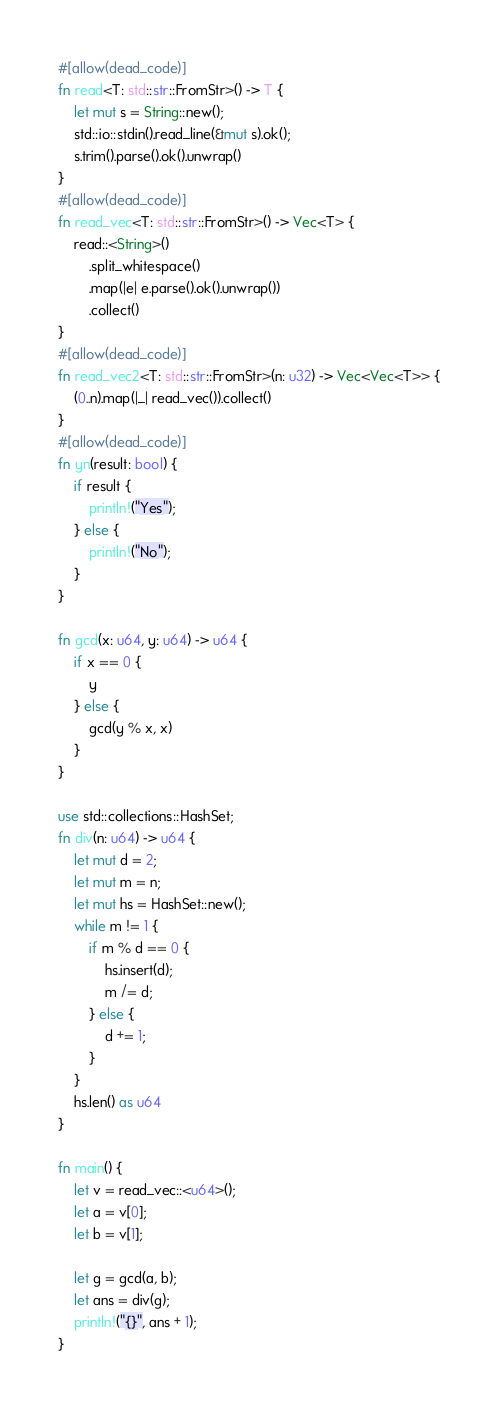<code> <loc_0><loc_0><loc_500><loc_500><_Rust_>#[allow(dead_code)]
fn read<T: std::str::FromStr>() -> T {
    let mut s = String::new();
    std::io::stdin().read_line(&mut s).ok();
    s.trim().parse().ok().unwrap()
}
#[allow(dead_code)]
fn read_vec<T: std::str::FromStr>() -> Vec<T> {
    read::<String>()
        .split_whitespace()
        .map(|e| e.parse().ok().unwrap())
        .collect()
}
#[allow(dead_code)]
fn read_vec2<T: std::str::FromStr>(n: u32) -> Vec<Vec<T>> {
    (0..n).map(|_| read_vec()).collect()
}
#[allow(dead_code)]
fn yn(result: bool) {
    if result {
        println!("Yes");
    } else {
        println!("No");
    }
}

fn gcd(x: u64, y: u64) -> u64 {
    if x == 0 {
        y
    } else {
        gcd(y % x, x)
    }
}

use std::collections::HashSet;
fn div(n: u64) -> u64 {
    let mut d = 2;
    let mut m = n;
    let mut hs = HashSet::new();
    while m != 1 {
        if m % d == 0 {
            hs.insert(d);
            m /= d;
        } else {
            d += 1;
        }
    }
    hs.len() as u64
}

fn main() {
    let v = read_vec::<u64>();
    let a = v[0];
    let b = v[1];

    let g = gcd(a, b);
    let ans = div(g);
    println!("{}", ans + 1);
}
</code> 